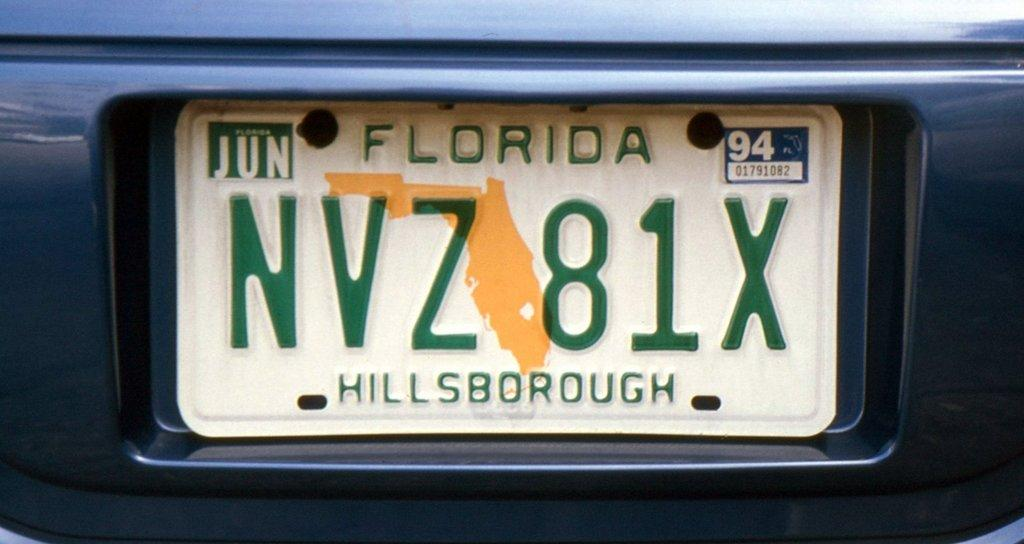<image>
Provide a brief description of the given image. A Florida license plate with the number NVZ 81X is on the bumper of a vehicle. 